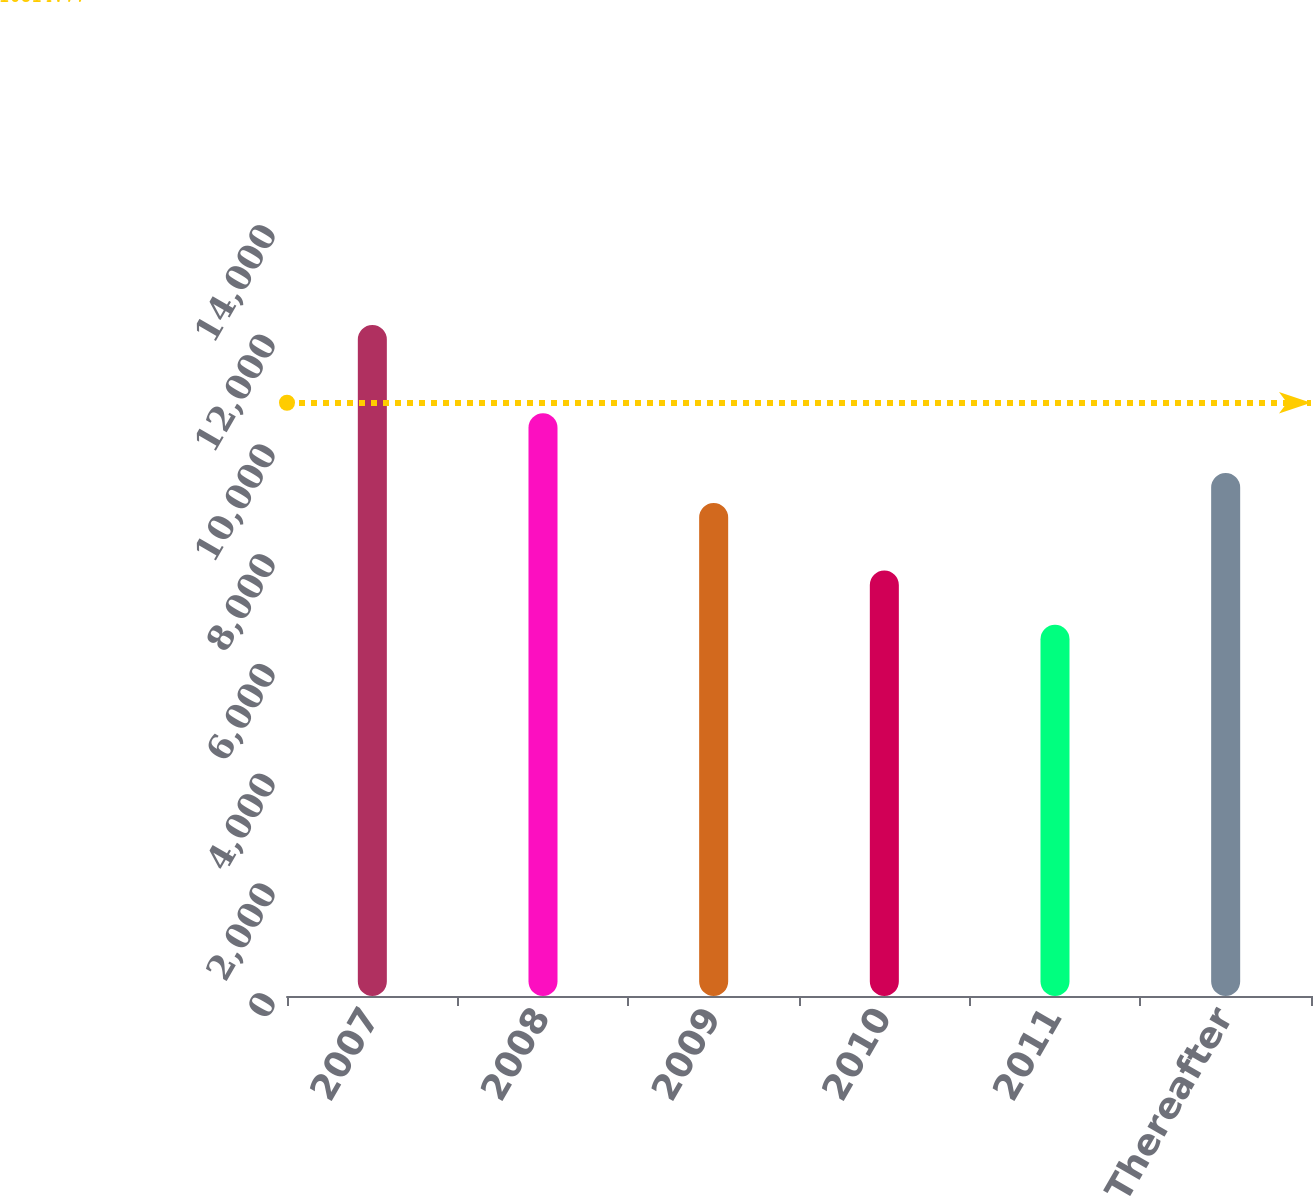Convert chart. <chart><loc_0><loc_0><loc_500><loc_500><bar_chart><fcel>2007<fcel>2008<fcel>2009<fcel>2010<fcel>2011<fcel>Thereafter<nl><fcel>12232<fcel>10624<fcel>8986<fcel>7755<fcel>6767<fcel>9532.5<nl></chart> 